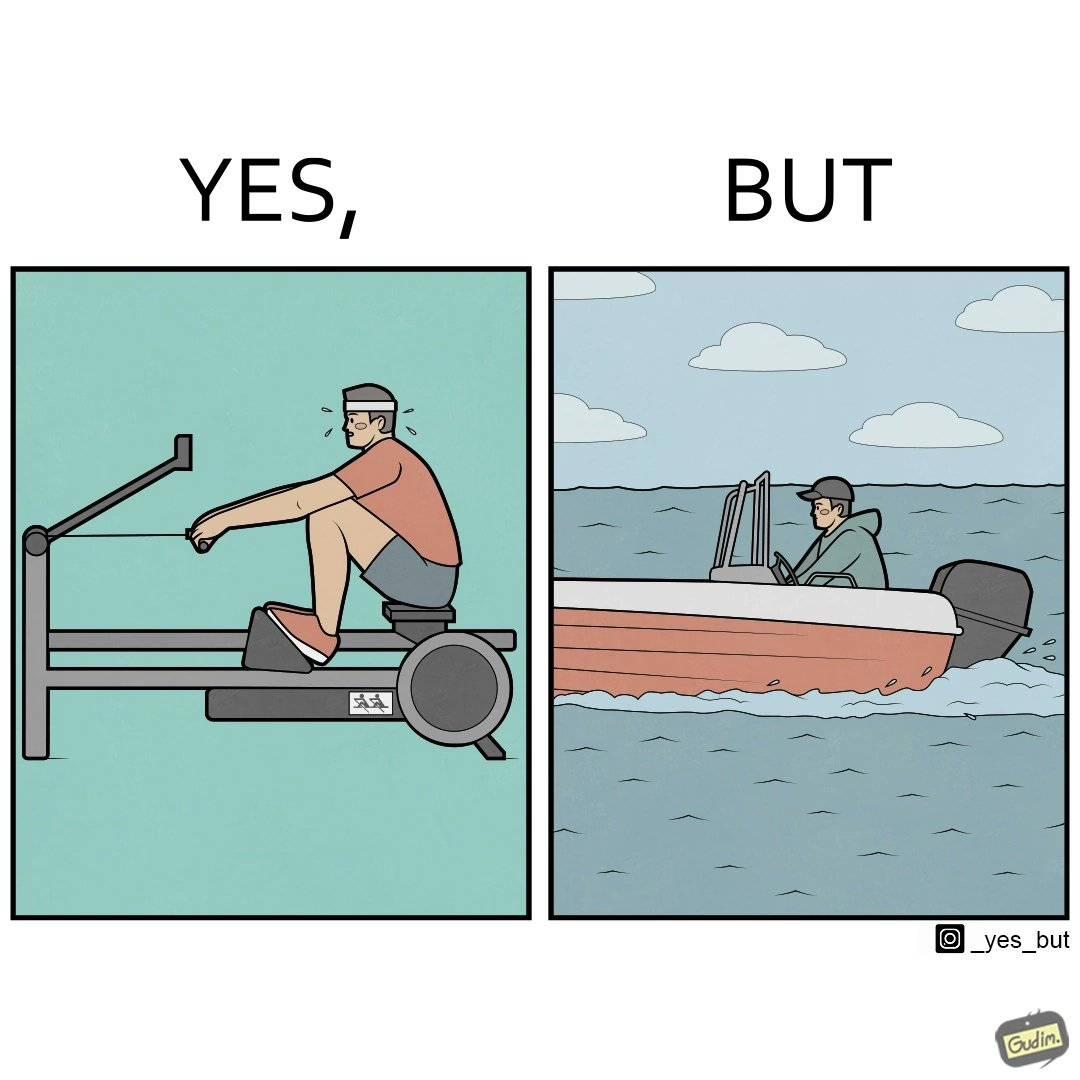Is this image satirical or non-satirical? Yes, this image is satirical. 